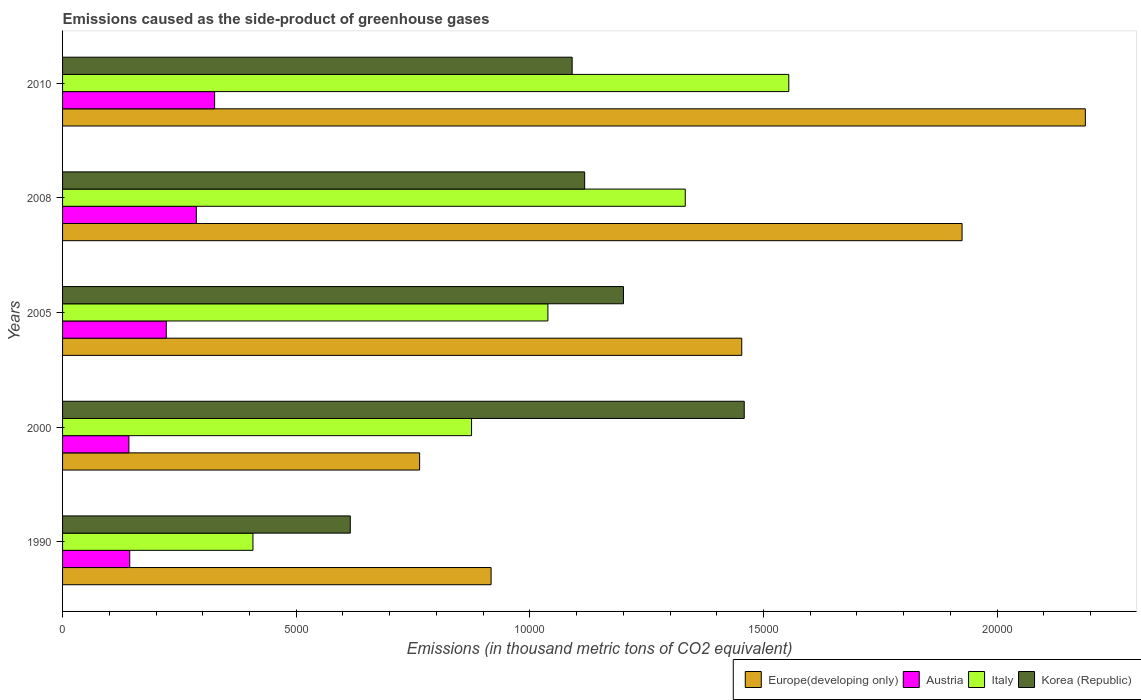How many different coloured bars are there?
Offer a very short reply. 4. How many groups of bars are there?
Offer a very short reply. 5. Are the number of bars per tick equal to the number of legend labels?
Give a very brief answer. Yes. How many bars are there on the 3rd tick from the bottom?
Your answer should be very brief. 4. What is the label of the 3rd group of bars from the top?
Provide a short and direct response. 2005. In how many cases, is the number of bars for a given year not equal to the number of legend labels?
Offer a very short reply. 0. What is the emissions caused as the side-product of greenhouse gases in Italy in 2005?
Your answer should be very brief. 1.04e+04. Across all years, what is the maximum emissions caused as the side-product of greenhouse gases in Italy?
Your answer should be very brief. 1.55e+04. Across all years, what is the minimum emissions caused as the side-product of greenhouse gases in Italy?
Make the answer very short. 4074. In which year was the emissions caused as the side-product of greenhouse gases in Europe(developing only) maximum?
Keep it short and to the point. 2010. What is the total emissions caused as the side-product of greenhouse gases in Italy in the graph?
Keep it short and to the point. 5.21e+04. What is the difference between the emissions caused as the side-product of greenhouse gases in Europe(developing only) in 2000 and that in 2008?
Offer a terse response. -1.16e+04. What is the difference between the emissions caused as the side-product of greenhouse gases in Europe(developing only) in 1990 and the emissions caused as the side-product of greenhouse gases in Italy in 2010?
Make the answer very short. -6370.9. What is the average emissions caused as the side-product of greenhouse gases in Korea (Republic) per year?
Offer a terse response. 1.10e+04. In the year 1990, what is the difference between the emissions caused as the side-product of greenhouse gases in Europe(developing only) and emissions caused as the side-product of greenhouse gases in Austria?
Offer a very short reply. 7732.3. In how many years, is the emissions caused as the side-product of greenhouse gases in Korea (Republic) greater than 10000 thousand metric tons?
Provide a short and direct response. 4. What is the ratio of the emissions caused as the side-product of greenhouse gases in Korea (Republic) in 1990 to that in 2010?
Make the answer very short. 0.56. Is the emissions caused as the side-product of greenhouse gases in Italy in 2008 less than that in 2010?
Offer a terse response. Yes. What is the difference between the highest and the second highest emissions caused as the side-product of greenhouse gases in Europe(developing only)?
Ensure brevity in your answer.  2638. What is the difference between the highest and the lowest emissions caused as the side-product of greenhouse gases in Italy?
Ensure brevity in your answer.  1.15e+04. In how many years, is the emissions caused as the side-product of greenhouse gases in Korea (Republic) greater than the average emissions caused as the side-product of greenhouse gases in Korea (Republic) taken over all years?
Provide a succinct answer. 3. Is the sum of the emissions caused as the side-product of greenhouse gases in Korea (Republic) in 1990 and 2000 greater than the maximum emissions caused as the side-product of greenhouse gases in Austria across all years?
Offer a very short reply. Yes. Is it the case that in every year, the sum of the emissions caused as the side-product of greenhouse gases in Korea (Republic) and emissions caused as the side-product of greenhouse gases in Italy is greater than the emissions caused as the side-product of greenhouse gases in Europe(developing only)?
Your answer should be very brief. Yes. Are all the bars in the graph horizontal?
Provide a succinct answer. Yes. Where does the legend appear in the graph?
Your answer should be very brief. Bottom right. What is the title of the graph?
Keep it short and to the point. Emissions caused as the side-product of greenhouse gases. What is the label or title of the X-axis?
Your answer should be very brief. Emissions (in thousand metric tons of CO2 equivalent). What is the Emissions (in thousand metric tons of CO2 equivalent) in Europe(developing only) in 1990?
Give a very brief answer. 9170.1. What is the Emissions (in thousand metric tons of CO2 equivalent) in Austria in 1990?
Ensure brevity in your answer.  1437.8. What is the Emissions (in thousand metric tons of CO2 equivalent) of Italy in 1990?
Make the answer very short. 4074. What is the Emissions (in thousand metric tons of CO2 equivalent) in Korea (Republic) in 1990?
Offer a terse response. 6157.2. What is the Emissions (in thousand metric tons of CO2 equivalent) in Europe(developing only) in 2000?
Offer a very short reply. 7640.7. What is the Emissions (in thousand metric tons of CO2 equivalent) in Austria in 2000?
Your answer should be compact. 1419.5. What is the Emissions (in thousand metric tons of CO2 equivalent) in Italy in 2000?
Ensure brevity in your answer.  8752.3. What is the Emissions (in thousand metric tons of CO2 equivalent) in Korea (Republic) in 2000?
Offer a terse response. 1.46e+04. What is the Emissions (in thousand metric tons of CO2 equivalent) of Europe(developing only) in 2005?
Provide a succinct answer. 1.45e+04. What is the Emissions (in thousand metric tons of CO2 equivalent) of Austria in 2005?
Your response must be concise. 2219.5. What is the Emissions (in thousand metric tons of CO2 equivalent) in Italy in 2005?
Provide a succinct answer. 1.04e+04. What is the Emissions (in thousand metric tons of CO2 equivalent) of Korea (Republic) in 2005?
Make the answer very short. 1.20e+04. What is the Emissions (in thousand metric tons of CO2 equivalent) in Europe(developing only) in 2008?
Provide a short and direct response. 1.92e+04. What is the Emissions (in thousand metric tons of CO2 equivalent) of Austria in 2008?
Give a very brief answer. 2862.4. What is the Emissions (in thousand metric tons of CO2 equivalent) in Italy in 2008?
Offer a terse response. 1.33e+04. What is the Emissions (in thousand metric tons of CO2 equivalent) of Korea (Republic) in 2008?
Your response must be concise. 1.12e+04. What is the Emissions (in thousand metric tons of CO2 equivalent) in Europe(developing only) in 2010?
Your answer should be compact. 2.19e+04. What is the Emissions (in thousand metric tons of CO2 equivalent) in Austria in 2010?
Offer a terse response. 3254. What is the Emissions (in thousand metric tons of CO2 equivalent) of Italy in 2010?
Your answer should be very brief. 1.55e+04. What is the Emissions (in thousand metric tons of CO2 equivalent) in Korea (Republic) in 2010?
Provide a short and direct response. 1.09e+04. Across all years, what is the maximum Emissions (in thousand metric tons of CO2 equivalent) in Europe(developing only)?
Give a very brief answer. 2.19e+04. Across all years, what is the maximum Emissions (in thousand metric tons of CO2 equivalent) in Austria?
Your response must be concise. 3254. Across all years, what is the maximum Emissions (in thousand metric tons of CO2 equivalent) of Italy?
Your answer should be compact. 1.55e+04. Across all years, what is the maximum Emissions (in thousand metric tons of CO2 equivalent) in Korea (Republic)?
Offer a terse response. 1.46e+04. Across all years, what is the minimum Emissions (in thousand metric tons of CO2 equivalent) in Europe(developing only)?
Keep it short and to the point. 7640.7. Across all years, what is the minimum Emissions (in thousand metric tons of CO2 equivalent) in Austria?
Your answer should be very brief. 1419.5. Across all years, what is the minimum Emissions (in thousand metric tons of CO2 equivalent) of Italy?
Your answer should be compact. 4074. Across all years, what is the minimum Emissions (in thousand metric tons of CO2 equivalent) of Korea (Republic)?
Provide a short and direct response. 6157.2. What is the total Emissions (in thousand metric tons of CO2 equivalent) in Europe(developing only) in the graph?
Ensure brevity in your answer.  7.25e+04. What is the total Emissions (in thousand metric tons of CO2 equivalent) of Austria in the graph?
Keep it short and to the point. 1.12e+04. What is the total Emissions (in thousand metric tons of CO2 equivalent) of Italy in the graph?
Ensure brevity in your answer.  5.21e+04. What is the total Emissions (in thousand metric tons of CO2 equivalent) of Korea (Republic) in the graph?
Your answer should be compact. 5.48e+04. What is the difference between the Emissions (in thousand metric tons of CO2 equivalent) in Europe(developing only) in 1990 and that in 2000?
Your response must be concise. 1529.4. What is the difference between the Emissions (in thousand metric tons of CO2 equivalent) in Austria in 1990 and that in 2000?
Offer a terse response. 18.3. What is the difference between the Emissions (in thousand metric tons of CO2 equivalent) in Italy in 1990 and that in 2000?
Ensure brevity in your answer.  -4678.3. What is the difference between the Emissions (in thousand metric tons of CO2 equivalent) in Korea (Republic) in 1990 and that in 2000?
Offer a very short reply. -8430.1. What is the difference between the Emissions (in thousand metric tons of CO2 equivalent) in Europe(developing only) in 1990 and that in 2005?
Offer a terse response. -5364. What is the difference between the Emissions (in thousand metric tons of CO2 equivalent) of Austria in 1990 and that in 2005?
Offer a terse response. -781.7. What is the difference between the Emissions (in thousand metric tons of CO2 equivalent) in Italy in 1990 and that in 2005?
Your answer should be compact. -6312. What is the difference between the Emissions (in thousand metric tons of CO2 equivalent) of Korea (Republic) in 1990 and that in 2005?
Make the answer very short. -5846.1. What is the difference between the Emissions (in thousand metric tons of CO2 equivalent) in Europe(developing only) in 1990 and that in 2008?
Offer a terse response. -1.01e+04. What is the difference between the Emissions (in thousand metric tons of CO2 equivalent) in Austria in 1990 and that in 2008?
Keep it short and to the point. -1424.6. What is the difference between the Emissions (in thousand metric tons of CO2 equivalent) of Italy in 1990 and that in 2008?
Provide a succinct answer. -9251.4. What is the difference between the Emissions (in thousand metric tons of CO2 equivalent) of Korea (Republic) in 1990 and that in 2008?
Your answer should be very brief. -5015.7. What is the difference between the Emissions (in thousand metric tons of CO2 equivalent) of Europe(developing only) in 1990 and that in 2010?
Your answer should be very brief. -1.27e+04. What is the difference between the Emissions (in thousand metric tons of CO2 equivalent) in Austria in 1990 and that in 2010?
Your answer should be very brief. -1816.2. What is the difference between the Emissions (in thousand metric tons of CO2 equivalent) in Italy in 1990 and that in 2010?
Make the answer very short. -1.15e+04. What is the difference between the Emissions (in thousand metric tons of CO2 equivalent) of Korea (Republic) in 1990 and that in 2010?
Provide a short and direct response. -4747.8. What is the difference between the Emissions (in thousand metric tons of CO2 equivalent) of Europe(developing only) in 2000 and that in 2005?
Offer a terse response. -6893.4. What is the difference between the Emissions (in thousand metric tons of CO2 equivalent) of Austria in 2000 and that in 2005?
Offer a terse response. -800. What is the difference between the Emissions (in thousand metric tons of CO2 equivalent) of Italy in 2000 and that in 2005?
Your answer should be very brief. -1633.7. What is the difference between the Emissions (in thousand metric tons of CO2 equivalent) of Korea (Republic) in 2000 and that in 2005?
Keep it short and to the point. 2584. What is the difference between the Emissions (in thousand metric tons of CO2 equivalent) in Europe(developing only) in 2000 and that in 2008?
Provide a succinct answer. -1.16e+04. What is the difference between the Emissions (in thousand metric tons of CO2 equivalent) in Austria in 2000 and that in 2008?
Provide a short and direct response. -1442.9. What is the difference between the Emissions (in thousand metric tons of CO2 equivalent) in Italy in 2000 and that in 2008?
Ensure brevity in your answer.  -4573.1. What is the difference between the Emissions (in thousand metric tons of CO2 equivalent) in Korea (Republic) in 2000 and that in 2008?
Offer a very short reply. 3414.4. What is the difference between the Emissions (in thousand metric tons of CO2 equivalent) of Europe(developing only) in 2000 and that in 2010?
Your response must be concise. -1.42e+04. What is the difference between the Emissions (in thousand metric tons of CO2 equivalent) in Austria in 2000 and that in 2010?
Your response must be concise. -1834.5. What is the difference between the Emissions (in thousand metric tons of CO2 equivalent) in Italy in 2000 and that in 2010?
Offer a terse response. -6788.7. What is the difference between the Emissions (in thousand metric tons of CO2 equivalent) of Korea (Republic) in 2000 and that in 2010?
Give a very brief answer. 3682.3. What is the difference between the Emissions (in thousand metric tons of CO2 equivalent) of Europe(developing only) in 2005 and that in 2008?
Make the answer very short. -4714.9. What is the difference between the Emissions (in thousand metric tons of CO2 equivalent) in Austria in 2005 and that in 2008?
Offer a very short reply. -642.9. What is the difference between the Emissions (in thousand metric tons of CO2 equivalent) in Italy in 2005 and that in 2008?
Keep it short and to the point. -2939.4. What is the difference between the Emissions (in thousand metric tons of CO2 equivalent) in Korea (Republic) in 2005 and that in 2008?
Provide a succinct answer. 830.4. What is the difference between the Emissions (in thousand metric tons of CO2 equivalent) of Europe(developing only) in 2005 and that in 2010?
Offer a terse response. -7352.9. What is the difference between the Emissions (in thousand metric tons of CO2 equivalent) in Austria in 2005 and that in 2010?
Your answer should be compact. -1034.5. What is the difference between the Emissions (in thousand metric tons of CO2 equivalent) of Italy in 2005 and that in 2010?
Your response must be concise. -5155. What is the difference between the Emissions (in thousand metric tons of CO2 equivalent) of Korea (Republic) in 2005 and that in 2010?
Keep it short and to the point. 1098.3. What is the difference between the Emissions (in thousand metric tons of CO2 equivalent) of Europe(developing only) in 2008 and that in 2010?
Give a very brief answer. -2638. What is the difference between the Emissions (in thousand metric tons of CO2 equivalent) in Austria in 2008 and that in 2010?
Your answer should be very brief. -391.6. What is the difference between the Emissions (in thousand metric tons of CO2 equivalent) in Italy in 2008 and that in 2010?
Keep it short and to the point. -2215.6. What is the difference between the Emissions (in thousand metric tons of CO2 equivalent) in Korea (Republic) in 2008 and that in 2010?
Offer a very short reply. 267.9. What is the difference between the Emissions (in thousand metric tons of CO2 equivalent) of Europe(developing only) in 1990 and the Emissions (in thousand metric tons of CO2 equivalent) of Austria in 2000?
Provide a succinct answer. 7750.6. What is the difference between the Emissions (in thousand metric tons of CO2 equivalent) of Europe(developing only) in 1990 and the Emissions (in thousand metric tons of CO2 equivalent) of Italy in 2000?
Keep it short and to the point. 417.8. What is the difference between the Emissions (in thousand metric tons of CO2 equivalent) in Europe(developing only) in 1990 and the Emissions (in thousand metric tons of CO2 equivalent) in Korea (Republic) in 2000?
Give a very brief answer. -5417.2. What is the difference between the Emissions (in thousand metric tons of CO2 equivalent) in Austria in 1990 and the Emissions (in thousand metric tons of CO2 equivalent) in Italy in 2000?
Give a very brief answer. -7314.5. What is the difference between the Emissions (in thousand metric tons of CO2 equivalent) in Austria in 1990 and the Emissions (in thousand metric tons of CO2 equivalent) in Korea (Republic) in 2000?
Make the answer very short. -1.31e+04. What is the difference between the Emissions (in thousand metric tons of CO2 equivalent) in Italy in 1990 and the Emissions (in thousand metric tons of CO2 equivalent) in Korea (Republic) in 2000?
Provide a short and direct response. -1.05e+04. What is the difference between the Emissions (in thousand metric tons of CO2 equivalent) of Europe(developing only) in 1990 and the Emissions (in thousand metric tons of CO2 equivalent) of Austria in 2005?
Keep it short and to the point. 6950.6. What is the difference between the Emissions (in thousand metric tons of CO2 equivalent) of Europe(developing only) in 1990 and the Emissions (in thousand metric tons of CO2 equivalent) of Italy in 2005?
Your answer should be very brief. -1215.9. What is the difference between the Emissions (in thousand metric tons of CO2 equivalent) in Europe(developing only) in 1990 and the Emissions (in thousand metric tons of CO2 equivalent) in Korea (Republic) in 2005?
Give a very brief answer. -2833.2. What is the difference between the Emissions (in thousand metric tons of CO2 equivalent) in Austria in 1990 and the Emissions (in thousand metric tons of CO2 equivalent) in Italy in 2005?
Make the answer very short. -8948.2. What is the difference between the Emissions (in thousand metric tons of CO2 equivalent) in Austria in 1990 and the Emissions (in thousand metric tons of CO2 equivalent) in Korea (Republic) in 2005?
Your response must be concise. -1.06e+04. What is the difference between the Emissions (in thousand metric tons of CO2 equivalent) of Italy in 1990 and the Emissions (in thousand metric tons of CO2 equivalent) of Korea (Republic) in 2005?
Offer a terse response. -7929.3. What is the difference between the Emissions (in thousand metric tons of CO2 equivalent) in Europe(developing only) in 1990 and the Emissions (in thousand metric tons of CO2 equivalent) in Austria in 2008?
Offer a terse response. 6307.7. What is the difference between the Emissions (in thousand metric tons of CO2 equivalent) in Europe(developing only) in 1990 and the Emissions (in thousand metric tons of CO2 equivalent) in Italy in 2008?
Your answer should be compact. -4155.3. What is the difference between the Emissions (in thousand metric tons of CO2 equivalent) of Europe(developing only) in 1990 and the Emissions (in thousand metric tons of CO2 equivalent) of Korea (Republic) in 2008?
Your answer should be compact. -2002.8. What is the difference between the Emissions (in thousand metric tons of CO2 equivalent) in Austria in 1990 and the Emissions (in thousand metric tons of CO2 equivalent) in Italy in 2008?
Your answer should be very brief. -1.19e+04. What is the difference between the Emissions (in thousand metric tons of CO2 equivalent) in Austria in 1990 and the Emissions (in thousand metric tons of CO2 equivalent) in Korea (Republic) in 2008?
Your answer should be very brief. -9735.1. What is the difference between the Emissions (in thousand metric tons of CO2 equivalent) in Italy in 1990 and the Emissions (in thousand metric tons of CO2 equivalent) in Korea (Republic) in 2008?
Make the answer very short. -7098.9. What is the difference between the Emissions (in thousand metric tons of CO2 equivalent) in Europe(developing only) in 1990 and the Emissions (in thousand metric tons of CO2 equivalent) in Austria in 2010?
Provide a short and direct response. 5916.1. What is the difference between the Emissions (in thousand metric tons of CO2 equivalent) of Europe(developing only) in 1990 and the Emissions (in thousand metric tons of CO2 equivalent) of Italy in 2010?
Provide a succinct answer. -6370.9. What is the difference between the Emissions (in thousand metric tons of CO2 equivalent) in Europe(developing only) in 1990 and the Emissions (in thousand metric tons of CO2 equivalent) in Korea (Republic) in 2010?
Your answer should be very brief. -1734.9. What is the difference between the Emissions (in thousand metric tons of CO2 equivalent) of Austria in 1990 and the Emissions (in thousand metric tons of CO2 equivalent) of Italy in 2010?
Offer a very short reply. -1.41e+04. What is the difference between the Emissions (in thousand metric tons of CO2 equivalent) of Austria in 1990 and the Emissions (in thousand metric tons of CO2 equivalent) of Korea (Republic) in 2010?
Provide a short and direct response. -9467.2. What is the difference between the Emissions (in thousand metric tons of CO2 equivalent) in Italy in 1990 and the Emissions (in thousand metric tons of CO2 equivalent) in Korea (Republic) in 2010?
Make the answer very short. -6831. What is the difference between the Emissions (in thousand metric tons of CO2 equivalent) in Europe(developing only) in 2000 and the Emissions (in thousand metric tons of CO2 equivalent) in Austria in 2005?
Provide a succinct answer. 5421.2. What is the difference between the Emissions (in thousand metric tons of CO2 equivalent) of Europe(developing only) in 2000 and the Emissions (in thousand metric tons of CO2 equivalent) of Italy in 2005?
Ensure brevity in your answer.  -2745.3. What is the difference between the Emissions (in thousand metric tons of CO2 equivalent) of Europe(developing only) in 2000 and the Emissions (in thousand metric tons of CO2 equivalent) of Korea (Republic) in 2005?
Make the answer very short. -4362.6. What is the difference between the Emissions (in thousand metric tons of CO2 equivalent) in Austria in 2000 and the Emissions (in thousand metric tons of CO2 equivalent) in Italy in 2005?
Offer a terse response. -8966.5. What is the difference between the Emissions (in thousand metric tons of CO2 equivalent) of Austria in 2000 and the Emissions (in thousand metric tons of CO2 equivalent) of Korea (Republic) in 2005?
Give a very brief answer. -1.06e+04. What is the difference between the Emissions (in thousand metric tons of CO2 equivalent) in Italy in 2000 and the Emissions (in thousand metric tons of CO2 equivalent) in Korea (Republic) in 2005?
Give a very brief answer. -3251. What is the difference between the Emissions (in thousand metric tons of CO2 equivalent) in Europe(developing only) in 2000 and the Emissions (in thousand metric tons of CO2 equivalent) in Austria in 2008?
Keep it short and to the point. 4778.3. What is the difference between the Emissions (in thousand metric tons of CO2 equivalent) in Europe(developing only) in 2000 and the Emissions (in thousand metric tons of CO2 equivalent) in Italy in 2008?
Your answer should be compact. -5684.7. What is the difference between the Emissions (in thousand metric tons of CO2 equivalent) in Europe(developing only) in 2000 and the Emissions (in thousand metric tons of CO2 equivalent) in Korea (Republic) in 2008?
Your answer should be very brief. -3532.2. What is the difference between the Emissions (in thousand metric tons of CO2 equivalent) of Austria in 2000 and the Emissions (in thousand metric tons of CO2 equivalent) of Italy in 2008?
Give a very brief answer. -1.19e+04. What is the difference between the Emissions (in thousand metric tons of CO2 equivalent) of Austria in 2000 and the Emissions (in thousand metric tons of CO2 equivalent) of Korea (Republic) in 2008?
Make the answer very short. -9753.4. What is the difference between the Emissions (in thousand metric tons of CO2 equivalent) of Italy in 2000 and the Emissions (in thousand metric tons of CO2 equivalent) of Korea (Republic) in 2008?
Keep it short and to the point. -2420.6. What is the difference between the Emissions (in thousand metric tons of CO2 equivalent) in Europe(developing only) in 2000 and the Emissions (in thousand metric tons of CO2 equivalent) in Austria in 2010?
Keep it short and to the point. 4386.7. What is the difference between the Emissions (in thousand metric tons of CO2 equivalent) of Europe(developing only) in 2000 and the Emissions (in thousand metric tons of CO2 equivalent) of Italy in 2010?
Your response must be concise. -7900.3. What is the difference between the Emissions (in thousand metric tons of CO2 equivalent) of Europe(developing only) in 2000 and the Emissions (in thousand metric tons of CO2 equivalent) of Korea (Republic) in 2010?
Keep it short and to the point. -3264.3. What is the difference between the Emissions (in thousand metric tons of CO2 equivalent) of Austria in 2000 and the Emissions (in thousand metric tons of CO2 equivalent) of Italy in 2010?
Make the answer very short. -1.41e+04. What is the difference between the Emissions (in thousand metric tons of CO2 equivalent) in Austria in 2000 and the Emissions (in thousand metric tons of CO2 equivalent) in Korea (Republic) in 2010?
Your answer should be compact. -9485.5. What is the difference between the Emissions (in thousand metric tons of CO2 equivalent) in Italy in 2000 and the Emissions (in thousand metric tons of CO2 equivalent) in Korea (Republic) in 2010?
Provide a succinct answer. -2152.7. What is the difference between the Emissions (in thousand metric tons of CO2 equivalent) in Europe(developing only) in 2005 and the Emissions (in thousand metric tons of CO2 equivalent) in Austria in 2008?
Your response must be concise. 1.17e+04. What is the difference between the Emissions (in thousand metric tons of CO2 equivalent) in Europe(developing only) in 2005 and the Emissions (in thousand metric tons of CO2 equivalent) in Italy in 2008?
Offer a terse response. 1208.7. What is the difference between the Emissions (in thousand metric tons of CO2 equivalent) of Europe(developing only) in 2005 and the Emissions (in thousand metric tons of CO2 equivalent) of Korea (Republic) in 2008?
Make the answer very short. 3361.2. What is the difference between the Emissions (in thousand metric tons of CO2 equivalent) of Austria in 2005 and the Emissions (in thousand metric tons of CO2 equivalent) of Italy in 2008?
Offer a terse response. -1.11e+04. What is the difference between the Emissions (in thousand metric tons of CO2 equivalent) of Austria in 2005 and the Emissions (in thousand metric tons of CO2 equivalent) of Korea (Republic) in 2008?
Offer a terse response. -8953.4. What is the difference between the Emissions (in thousand metric tons of CO2 equivalent) in Italy in 2005 and the Emissions (in thousand metric tons of CO2 equivalent) in Korea (Republic) in 2008?
Ensure brevity in your answer.  -786.9. What is the difference between the Emissions (in thousand metric tons of CO2 equivalent) in Europe(developing only) in 2005 and the Emissions (in thousand metric tons of CO2 equivalent) in Austria in 2010?
Your answer should be compact. 1.13e+04. What is the difference between the Emissions (in thousand metric tons of CO2 equivalent) in Europe(developing only) in 2005 and the Emissions (in thousand metric tons of CO2 equivalent) in Italy in 2010?
Provide a succinct answer. -1006.9. What is the difference between the Emissions (in thousand metric tons of CO2 equivalent) of Europe(developing only) in 2005 and the Emissions (in thousand metric tons of CO2 equivalent) of Korea (Republic) in 2010?
Your answer should be very brief. 3629.1. What is the difference between the Emissions (in thousand metric tons of CO2 equivalent) in Austria in 2005 and the Emissions (in thousand metric tons of CO2 equivalent) in Italy in 2010?
Your response must be concise. -1.33e+04. What is the difference between the Emissions (in thousand metric tons of CO2 equivalent) in Austria in 2005 and the Emissions (in thousand metric tons of CO2 equivalent) in Korea (Republic) in 2010?
Offer a terse response. -8685.5. What is the difference between the Emissions (in thousand metric tons of CO2 equivalent) of Italy in 2005 and the Emissions (in thousand metric tons of CO2 equivalent) of Korea (Republic) in 2010?
Offer a very short reply. -519. What is the difference between the Emissions (in thousand metric tons of CO2 equivalent) in Europe(developing only) in 2008 and the Emissions (in thousand metric tons of CO2 equivalent) in Austria in 2010?
Keep it short and to the point. 1.60e+04. What is the difference between the Emissions (in thousand metric tons of CO2 equivalent) of Europe(developing only) in 2008 and the Emissions (in thousand metric tons of CO2 equivalent) of Italy in 2010?
Keep it short and to the point. 3708. What is the difference between the Emissions (in thousand metric tons of CO2 equivalent) in Europe(developing only) in 2008 and the Emissions (in thousand metric tons of CO2 equivalent) in Korea (Republic) in 2010?
Give a very brief answer. 8344. What is the difference between the Emissions (in thousand metric tons of CO2 equivalent) of Austria in 2008 and the Emissions (in thousand metric tons of CO2 equivalent) of Italy in 2010?
Make the answer very short. -1.27e+04. What is the difference between the Emissions (in thousand metric tons of CO2 equivalent) of Austria in 2008 and the Emissions (in thousand metric tons of CO2 equivalent) of Korea (Republic) in 2010?
Give a very brief answer. -8042.6. What is the difference between the Emissions (in thousand metric tons of CO2 equivalent) in Italy in 2008 and the Emissions (in thousand metric tons of CO2 equivalent) in Korea (Republic) in 2010?
Offer a terse response. 2420.4. What is the average Emissions (in thousand metric tons of CO2 equivalent) of Europe(developing only) per year?
Make the answer very short. 1.45e+04. What is the average Emissions (in thousand metric tons of CO2 equivalent) in Austria per year?
Provide a succinct answer. 2238.64. What is the average Emissions (in thousand metric tons of CO2 equivalent) of Italy per year?
Offer a very short reply. 1.04e+04. What is the average Emissions (in thousand metric tons of CO2 equivalent) of Korea (Republic) per year?
Your response must be concise. 1.10e+04. In the year 1990, what is the difference between the Emissions (in thousand metric tons of CO2 equivalent) of Europe(developing only) and Emissions (in thousand metric tons of CO2 equivalent) of Austria?
Your answer should be compact. 7732.3. In the year 1990, what is the difference between the Emissions (in thousand metric tons of CO2 equivalent) in Europe(developing only) and Emissions (in thousand metric tons of CO2 equivalent) in Italy?
Offer a terse response. 5096.1. In the year 1990, what is the difference between the Emissions (in thousand metric tons of CO2 equivalent) in Europe(developing only) and Emissions (in thousand metric tons of CO2 equivalent) in Korea (Republic)?
Make the answer very short. 3012.9. In the year 1990, what is the difference between the Emissions (in thousand metric tons of CO2 equivalent) of Austria and Emissions (in thousand metric tons of CO2 equivalent) of Italy?
Provide a short and direct response. -2636.2. In the year 1990, what is the difference between the Emissions (in thousand metric tons of CO2 equivalent) in Austria and Emissions (in thousand metric tons of CO2 equivalent) in Korea (Republic)?
Give a very brief answer. -4719.4. In the year 1990, what is the difference between the Emissions (in thousand metric tons of CO2 equivalent) of Italy and Emissions (in thousand metric tons of CO2 equivalent) of Korea (Republic)?
Offer a terse response. -2083.2. In the year 2000, what is the difference between the Emissions (in thousand metric tons of CO2 equivalent) of Europe(developing only) and Emissions (in thousand metric tons of CO2 equivalent) of Austria?
Keep it short and to the point. 6221.2. In the year 2000, what is the difference between the Emissions (in thousand metric tons of CO2 equivalent) in Europe(developing only) and Emissions (in thousand metric tons of CO2 equivalent) in Italy?
Keep it short and to the point. -1111.6. In the year 2000, what is the difference between the Emissions (in thousand metric tons of CO2 equivalent) of Europe(developing only) and Emissions (in thousand metric tons of CO2 equivalent) of Korea (Republic)?
Offer a very short reply. -6946.6. In the year 2000, what is the difference between the Emissions (in thousand metric tons of CO2 equivalent) of Austria and Emissions (in thousand metric tons of CO2 equivalent) of Italy?
Offer a very short reply. -7332.8. In the year 2000, what is the difference between the Emissions (in thousand metric tons of CO2 equivalent) of Austria and Emissions (in thousand metric tons of CO2 equivalent) of Korea (Republic)?
Provide a succinct answer. -1.32e+04. In the year 2000, what is the difference between the Emissions (in thousand metric tons of CO2 equivalent) in Italy and Emissions (in thousand metric tons of CO2 equivalent) in Korea (Republic)?
Your answer should be compact. -5835. In the year 2005, what is the difference between the Emissions (in thousand metric tons of CO2 equivalent) in Europe(developing only) and Emissions (in thousand metric tons of CO2 equivalent) in Austria?
Your answer should be compact. 1.23e+04. In the year 2005, what is the difference between the Emissions (in thousand metric tons of CO2 equivalent) of Europe(developing only) and Emissions (in thousand metric tons of CO2 equivalent) of Italy?
Offer a very short reply. 4148.1. In the year 2005, what is the difference between the Emissions (in thousand metric tons of CO2 equivalent) in Europe(developing only) and Emissions (in thousand metric tons of CO2 equivalent) in Korea (Republic)?
Keep it short and to the point. 2530.8. In the year 2005, what is the difference between the Emissions (in thousand metric tons of CO2 equivalent) of Austria and Emissions (in thousand metric tons of CO2 equivalent) of Italy?
Offer a terse response. -8166.5. In the year 2005, what is the difference between the Emissions (in thousand metric tons of CO2 equivalent) in Austria and Emissions (in thousand metric tons of CO2 equivalent) in Korea (Republic)?
Your answer should be compact. -9783.8. In the year 2005, what is the difference between the Emissions (in thousand metric tons of CO2 equivalent) in Italy and Emissions (in thousand metric tons of CO2 equivalent) in Korea (Republic)?
Keep it short and to the point. -1617.3. In the year 2008, what is the difference between the Emissions (in thousand metric tons of CO2 equivalent) of Europe(developing only) and Emissions (in thousand metric tons of CO2 equivalent) of Austria?
Provide a succinct answer. 1.64e+04. In the year 2008, what is the difference between the Emissions (in thousand metric tons of CO2 equivalent) in Europe(developing only) and Emissions (in thousand metric tons of CO2 equivalent) in Italy?
Provide a short and direct response. 5923.6. In the year 2008, what is the difference between the Emissions (in thousand metric tons of CO2 equivalent) in Europe(developing only) and Emissions (in thousand metric tons of CO2 equivalent) in Korea (Republic)?
Offer a very short reply. 8076.1. In the year 2008, what is the difference between the Emissions (in thousand metric tons of CO2 equivalent) in Austria and Emissions (in thousand metric tons of CO2 equivalent) in Italy?
Your answer should be compact. -1.05e+04. In the year 2008, what is the difference between the Emissions (in thousand metric tons of CO2 equivalent) in Austria and Emissions (in thousand metric tons of CO2 equivalent) in Korea (Republic)?
Keep it short and to the point. -8310.5. In the year 2008, what is the difference between the Emissions (in thousand metric tons of CO2 equivalent) in Italy and Emissions (in thousand metric tons of CO2 equivalent) in Korea (Republic)?
Ensure brevity in your answer.  2152.5. In the year 2010, what is the difference between the Emissions (in thousand metric tons of CO2 equivalent) in Europe(developing only) and Emissions (in thousand metric tons of CO2 equivalent) in Austria?
Make the answer very short. 1.86e+04. In the year 2010, what is the difference between the Emissions (in thousand metric tons of CO2 equivalent) of Europe(developing only) and Emissions (in thousand metric tons of CO2 equivalent) of Italy?
Your response must be concise. 6346. In the year 2010, what is the difference between the Emissions (in thousand metric tons of CO2 equivalent) in Europe(developing only) and Emissions (in thousand metric tons of CO2 equivalent) in Korea (Republic)?
Your answer should be very brief. 1.10e+04. In the year 2010, what is the difference between the Emissions (in thousand metric tons of CO2 equivalent) of Austria and Emissions (in thousand metric tons of CO2 equivalent) of Italy?
Provide a succinct answer. -1.23e+04. In the year 2010, what is the difference between the Emissions (in thousand metric tons of CO2 equivalent) of Austria and Emissions (in thousand metric tons of CO2 equivalent) of Korea (Republic)?
Provide a short and direct response. -7651. In the year 2010, what is the difference between the Emissions (in thousand metric tons of CO2 equivalent) of Italy and Emissions (in thousand metric tons of CO2 equivalent) of Korea (Republic)?
Keep it short and to the point. 4636. What is the ratio of the Emissions (in thousand metric tons of CO2 equivalent) in Europe(developing only) in 1990 to that in 2000?
Offer a very short reply. 1.2. What is the ratio of the Emissions (in thousand metric tons of CO2 equivalent) of Austria in 1990 to that in 2000?
Give a very brief answer. 1.01. What is the ratio of the Emissions (in thousand metric tons of CO2 equivalent) in Italy in 1990 to that in 2000?
Keep it short and to the point. 0.47. What is the ratio of the Emissions (in thousand metric tons of CO2 equivalent) of Korea (Republic) in 1990 to that in 2000?
Make the answer very short. 0.42. What is the ratio of the Emissions (in thousand metric tons of CO2 equivalent) in Europe(developing only) in 1990 to that in 2005?
Offer a terse response. 0.63. What is the ratio of the Emissions (in thousand metric tons of CO2 equivalent) of Austria in 1990 to that in 2005?
Your answer should be compact. 0.65. What is the ratio of the Emissions (in thousand metric tons of CO2 equivalent) in Italy in 1990 to that in 2005?
Offer a terse response. 0.39. What is the ratio of the Emissions (in thousand metric tons of CO2 equivalent) in Korea (Republic) in 1990 to that in 2005?
Keep it short and to the point. 0.51. What is the ratio of the Emissions (in thousand metric tons of CO2 equivalent) of Europe(developing only) in 1990 to that in 2008?
Offer a terse response. 0.48. What is the ratio of the Emissions (in thousand metric tons of CO2 equivalent) in Austria in 1990 to that in 2008?
Your answer should be compact. 0.5. What is the ratio of the Emissions (in thousand metric tons of CO2 equivalent) in Italy in 1990 to that in 2008?
Give a very brief answer. 0.31. What is the ratio of the Emissions (in thousand metric tons of CO2 equivalent) in Korea (Republic) in 1990 to that in 2008?
Offer a terse response. 0.55. What is the ratio of the Emissions (in thousand metric tons of CO2 equivalent) in Europe(developing only) in 1990 to that in 2010?
Ensure brevity in your answer.  0.42. What is the ratio of the Emissions (in thousand metric tons of CO2 equivalent) of Austria in 1990 to that in 2010?
Your answer should be compact. 0.44. What is the ratio of the Emissions (in thousand metric tons of CO2 equivalent) of Italy in 1990 to that in 2010?
Give a very brief answer. 0.26. What is the ratio of the Emissions (in thousand metric tons of CO2 equivalent) of Korea (Republic) in 1990 to that in 2010?
Give a very brief answer. 0.56. What is the ratio of the Emissions (in thousand metric tons of CO2 equivalent) of Europe(developing only) in 2000 to that in 2005?
Offer a terse response. 0.53. What is the ratio of the Emissions (in thousand metric tons of CO2 equivalent) in Austria in 2000 to that in 2005?
Your answer should be compact. 0.64. What is the ratio of the Emissions (in thousand metric tons of CO2 equivalent) in Italy in 2000 to that in 2005?
Offer a very short reply. 0.84. What is the ratio of the Emissions (in thousand metric tons of CO2 equivalent) in Korea (Republic) in 2000 to that in 2005?
Keep it short and to the point. 1.22. What is the ratio of the Emissions (in thousand metric tons of CO2 equivalent) in Europe(developing only) in 2000 to that in 2008?
Give a very brief answer. 0.4. What is the ratio of the Emissions (in thousand metric tons of CO2 equivalent) of Austria in 2000 to that in 2008?
Keep it short and to the point. 0.5. What is the ratio of the Emissions (in thousand metric tons of CO2 equivalent) of Italy in 2000 to that in 2008?
Your answer should be very brief. 0.66. What is the ratio of the Emissions (in thousand metric tons of CO2 equivalent) in Korea (Republic) in 2000 to that in 2008?
Make the answer very short. 1.31. What is the ratio of the Emissions (in thousand metric tons of CO2 equivalent) in Europe(developing only) in 2000 to that in 2010?
Your answer should be compact. 0.35. What is the ratio of the Emissions (in thousand metric tons of CO2 equivalent) of Austria in 2000 to that in 2010?
Offer a very short reply. 0.44. What is the ratio of the Emissions (in thousand metric tons of CO2 equivalent) of Italy in 2000 to that in 2010?
Your answer should be very brief. 0.56. What is the ratio of the Emissions (in thousand metric tons of CO2 equivalent) in Korea (Republic) in 2000 to that in 2010?
Make the answer very short. 1.34. What is the ratio of the Emissions (in thousand metric tons of CO2 equivalent) of Europe(developing only) in 2005 to that in 2008?
Provide a short and direct response. 0.76. What is the ratio of the Emissions (in thousand metric tons of CO2 equivalent) in Austria in 2005 to that in 2008?
Offer a terse response. 0.78. What is the ratio of the Emissions (in thousand metric tons of CO2 equivalent) in Italy in 2005 to that in 2008?
Offer a very short reply. 0.78. What is the ratio of the Emissions (in thousand metric tons of CO2 equivalent) of Korea (Republic) in 2005 to that in 2008?
Ensure brevity in your answer.  1.07. What is the ratio of the Emissions (in thousand metric tons of CO2 equivalent) of Europe(developing only) in 2005 to that in 2010?
Your answer should be compact. 0.66. What is the ratio of the Emissions (in thousand metric tons of CO2 equivalent) in Austria in 2005 to that in 2010?
Provide a succinct answer. 0.68. What is the ratio of the Emissions (in thousand metric tons of CO2 equivalent) of Italy in 2005 to that in 2010?
Your answer should be compact. 0.67. What is the ratio of the Emissions (in thousand metric tons of CO2 equivalent) in Korea (Republic) in 2005 to that in 2010?
Provide a short and direct response. 1.1. What is the ratio of the Emissions (in thousand metric tons of CO2 equivalent) in Europe(developing only) in 2008 to that in 2010?
Keep it short and to the point. 0.88. What is the ratio of the Emissions (in thousand metric tons of CO2 equivalent) in Austria in 2008 to that in 2010?
Your answer should be compact. 0.88. What is the ratio of the Emissions (in thousand metric tons of CO2 equivalent) in Italy in 2008 to that in 2010?
Ensure brevity in your answer.  0.86. What is the ratio of the Emissions (in thousand metric tons of CO2 equivalent) in Korea (Republic) in 2008 to that in 2010?
Your answer should be compact. 1.02. What is the difference between the highest and the second highest Emissions (in thousand metric tons of CO2 equivalent) of Europe(developing only)?
Your response must be concise. 2638. What is the difference between the highest and the second highest Emissions (in thousand metric tons of CO2 equivalent) of Austria?
Provide a short and direct response. 391.6. What is the difference between the highest and the second highest Emissions (in thousand metric tons of CO2 equivalent) in Italy?
Keep it short and to the point. 2215.6. What is the difference between the highest and the second highest Emissions (in thousand metric tons of CO2 equivalent) of Korea (Republic)?
Make the answer very short. 2584. What is the difference between the highest and the lowest Emissions (in thousand metric tons of CO2 equivalent) in Europe(developing only)?
Provide a short and direct response. 1.42e+04. What is the difference between the highest and the lowest Emissions (in thousand metric tons of CO2 equivalent) in Austria?
Your answer should be compact. 1834.5. What is the difference between the highest and the lowest Emissions (in thousand metric tons of CO2 equivalent) in Italy?
Provide a short and direct response. 1.15e+04. What is the difference between the highest and the lowest Emissions (in thousand metric tons of CO2 equivalent) in Korea (Republic)?
Your answer should be compact. 8430.1. 